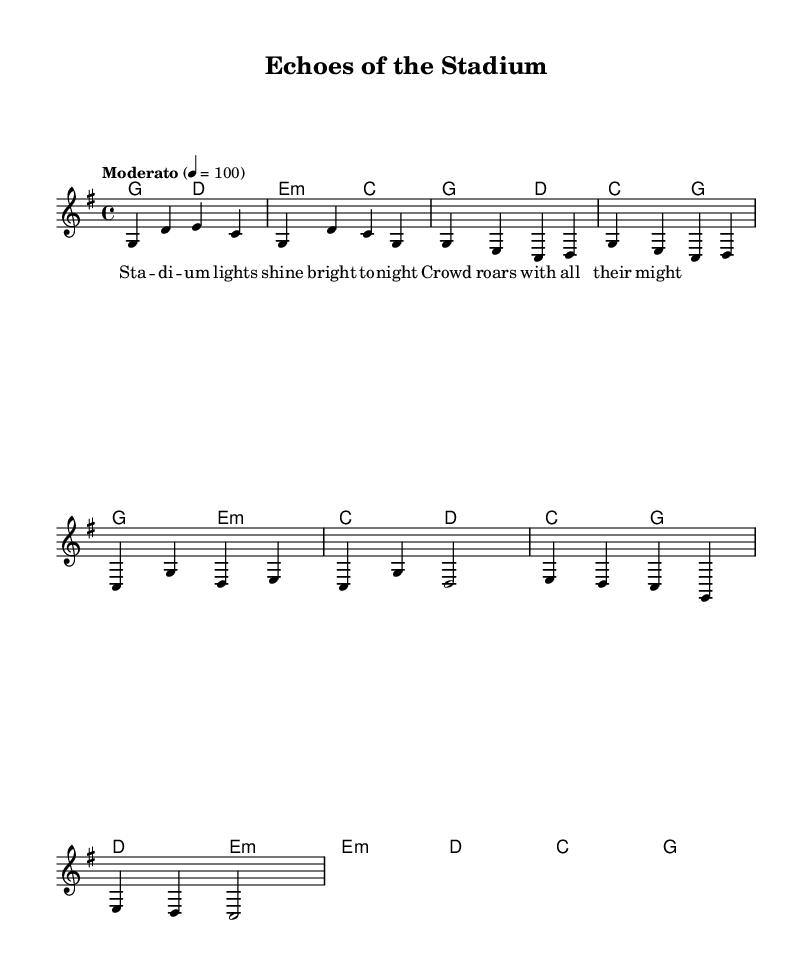What is the key signature of this music? The key signature is G major, which has one sharp (F#). This is indicated at the beginning of the score with the appropriate symbol denoting the sharp.
Answer: G major What is the time signature of this piece? The time signature is 4/4, as indicated at the beginning of the score. This means there are four beats in each measure, and the quarter note gets one beat.
Answer: 4/4 What is the tempo marking of the music? The tempo marking is "Moderato," set at a metronome marking of 100 beats per minute. This indicates a moderate pace for the performance of the piece.
Answer: Moderato How many measures are in the 'Intro' section? The 'Intro' section consists of 4 measures, which can be counted from the beginning of the music up to the first phrase break.
Answer: 4 measures What type of voicing is used in the melody? The voicing used in the melody is primarily in a single staff for a lead voice, focusing on a singular melodic line. This is typical for folk songs, emphasizing simplicity and clarity.
Answer: Lead voice What chord is played during the bridge section? The bridge section contains the E minor chord (e:m), which is indicated in the harmonies corresponding to the melody. This offers contrast and a change in harmonic texture.
Answer: E minor Which stadium atmosphere does the song evoke based on the lyrics? The lyrics evoke the atmosphere of an energetic and bright stadium night, highlighted by phrases such as "Lights shine bright" and "Crowd roars." This imagery is common in folk music reflecting community and events.
Answer: Stadium atmosphere 